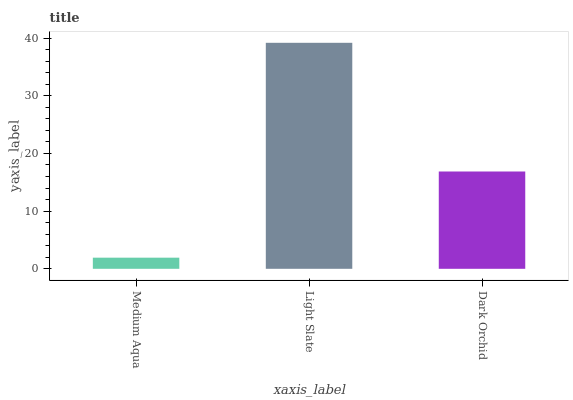Is Medium Aqua the minimum?
Answer yes or no. Yes. Is Light Slate the maximum?
Answer yes or no. Yes. Is Dark Orchid the minimum?
Answer yes or no. No. Is Dark Orchid the maximum?
Answer yes or no. No. Is Light Slate greater than Dark Orchid?
Answer yes or no. Yes. Is Dark Orchid less than Light Slate?
Answer yes or no. Yes. Is Dark Orchid greater than Light Slate?
Answer yes or no. No. Is Light Slate less than Dark Orchid?
Answer yes or no. No. Is Dark Orchid the high median?
Answer yes or no. Yes. Is Dark Orchid the low median?
Answer yes or no. Yes. Is Light Slate the high median?
Answer yes or no. No. Is Light Slate the low median?
Answer yes or no. No. 